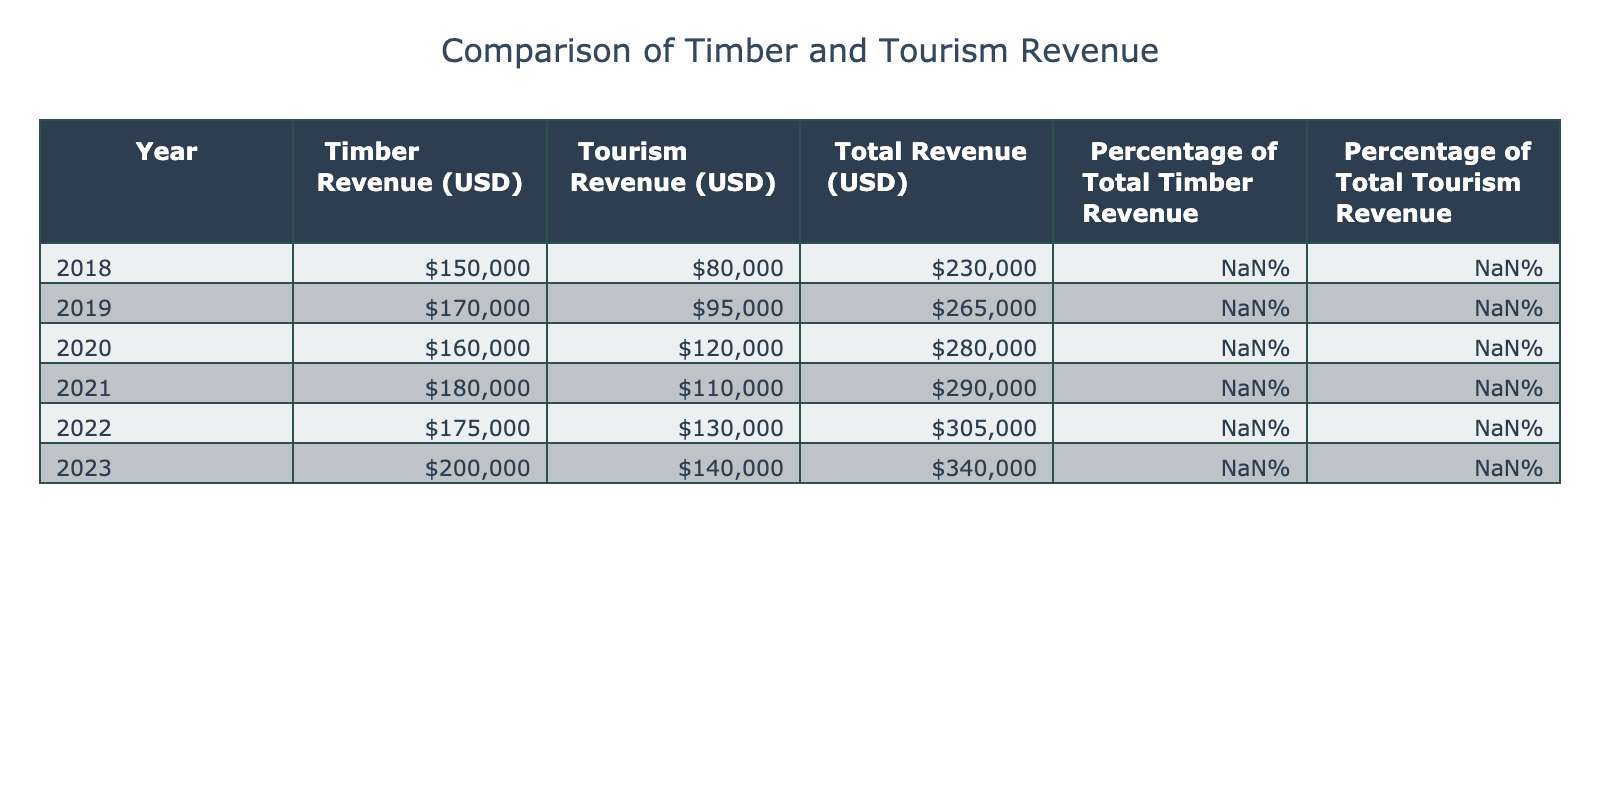What was the timber revenue in 2020? Referring to the table, the timber revenue for the year 2020 is listed directly under the Timber Revenue column. Upon checking that row, the timber revenue is 160,000.
Answer: 160000 Which year had the highest tourism revenue? To find the year with the highest tourism revenue, we look at the Tourism Revenue column and identify the maximum value. The highest tourism revenue is 140,000, which is in the year 2023.
Answer: 2023 What is the total revenue for 2021? The total revenue for 2021 can be found under the Total Revenue column for that year, which lists the figure as 290,000.
Answer: 290000 What is the difference in timber revenue between 2018 and 2022? To find the difference in timber revenue, we take the timber revenue for 2018 (150,000) and subtract the timber revenue for 2022 (175,000). This gives us 175,000 - 150,000 = 25,000.
Answer: 25000 Is the percentage of total timber revenue in 2023 higher than in 2019? Looking at the Percentage of Total Timber Revenue column, we find that in 2023 it is 58.82%, and in 2019 it is 64.15%. Since 58.82% is less than 64.15%, the statement is false.
Answer: No How much was the total revenue in 2019 compared to total tourism revenue in 2020? We first find the Total Revenue for 2019 from the table, which is 265,000, and for the Tourism Revenue in 2020, which is 120,000. The comparison shows that 265,000 (2019) is greater than 120,000 (2020).
Answer: 265000 is greater than 120000 What was the average timber revenue from 2018 to 2023? The timber revenues from 2018 to 2023 are 150,000, 170,000, 160,000, 180,000, 175,000, and 200,000. To find the average, we sum these values: 150,000 + 170,000 + 160,000 + 180,000 + 175,000 + 200,000 = 1,035,000. Then we divide by 6 (the number of years), giving us 1,035,000 / 6 = 172,500.
Answer: 172500 Which year showed the greatest percentage increase in tourism revenue compared to the previous year? We calculate the percentage change for each year starting from 2018. The calculations are: 2019 (118.75% increase from 80,000), 2020 (126.32% increase from 95,000), 2021 (91.58% decrease from 120,000), 2022 (118.18% increase from 110,000), and 2023 (107.69% increase from 130,000). The highest percentage increase was from 2019 to 2020 at 126.32%.
Answer: 2020 Looking at the timber revenue from 2021 to 2023, was there a consistent increase? Analyzing the timber revenues for 2021, 2022, and 2023 shows that the values were 180,000, 175,000, and 200,000 respectively. There is a decrease from 2021 to 2022, thus indicating that the timber revenue did not consistently increase during this period.
Answer: No 